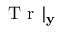Convert formula to latex. <formula><loc_0><loc_0><loc_500><loc_500>T r | _ { y }</formula> 